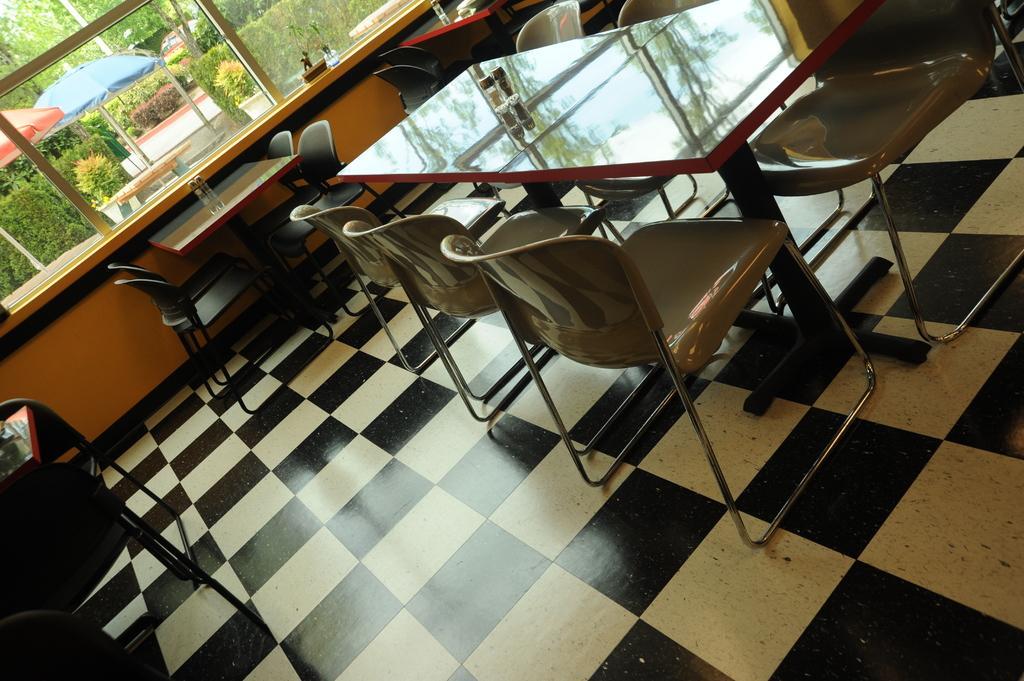Could you give a brief overview of what you see in this image? This image consists of chairs and tables. It looks like a restaurant. At the bottom, there is a floor. In the front, there is a window through which we can see the umbrellas and plants. 